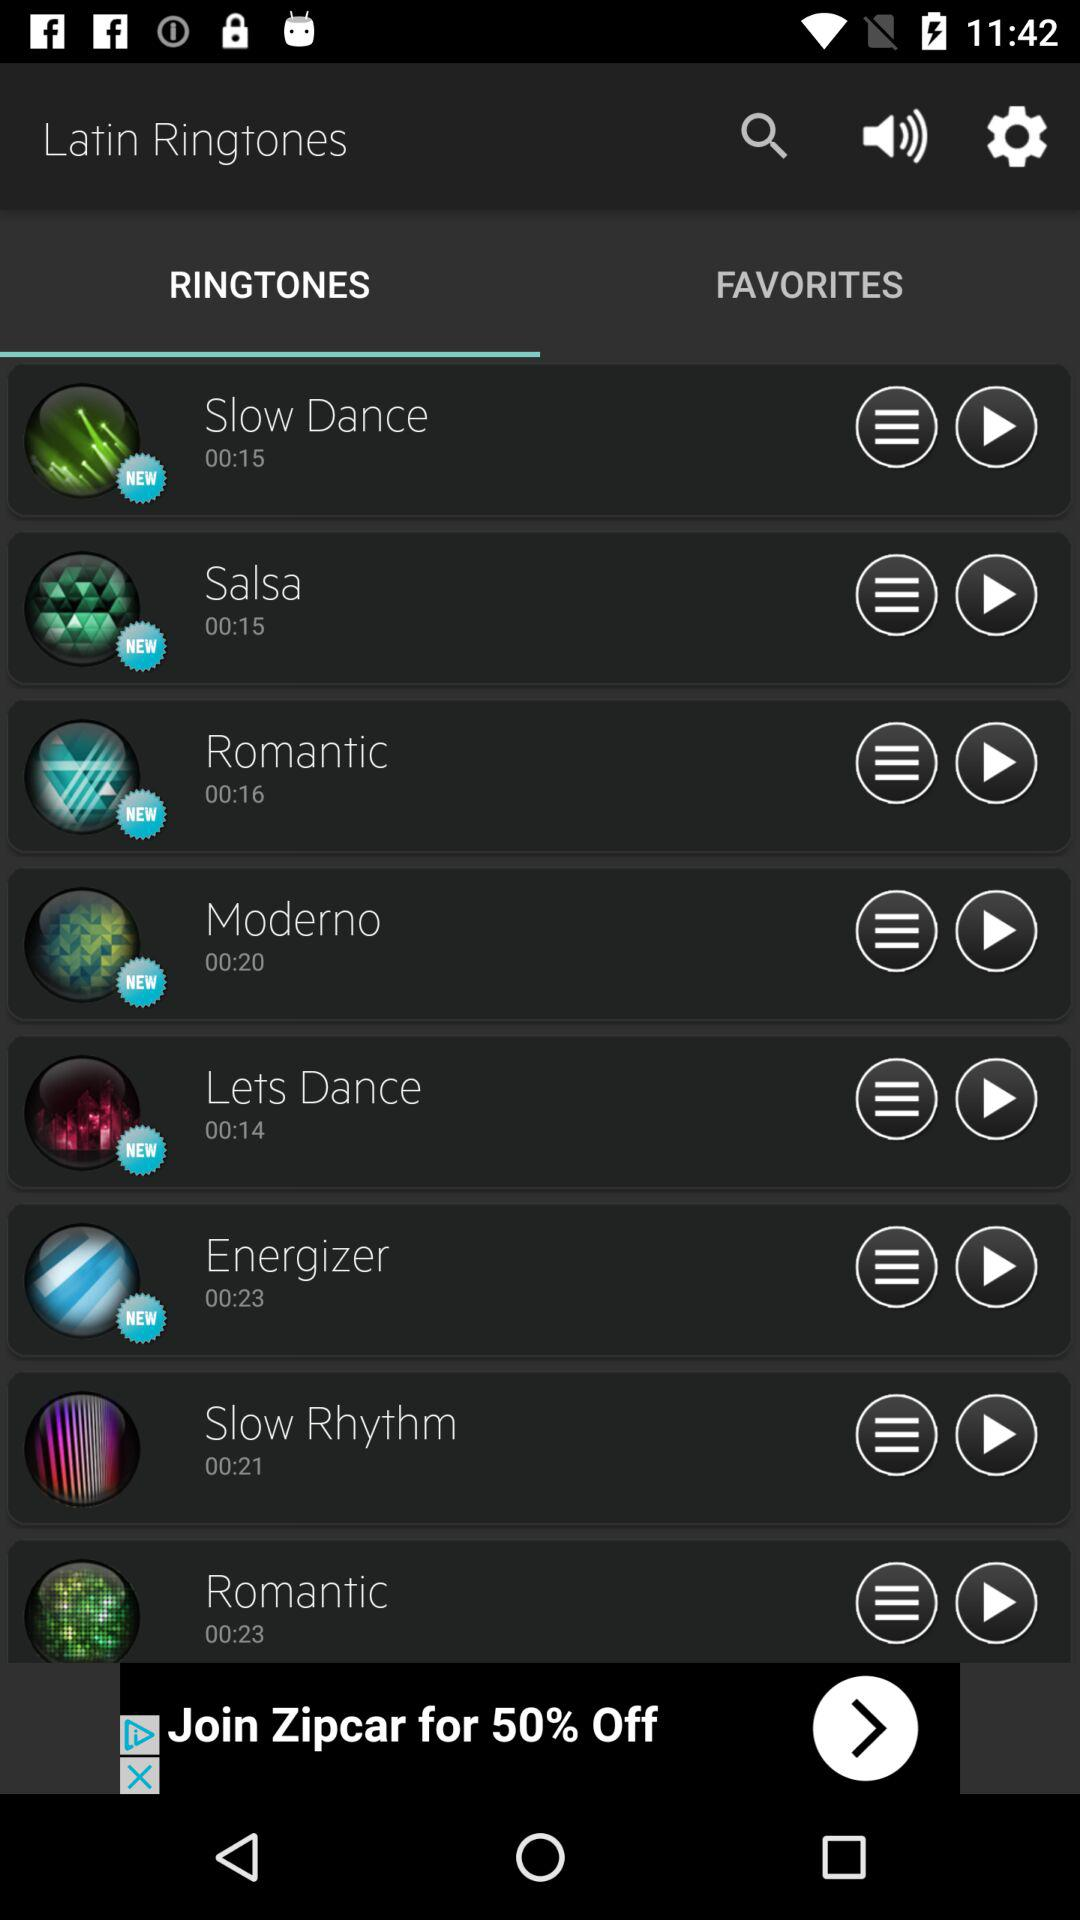Is the ringtone "Lets Dance" new or old? The ringtone "Lets Dance" is new. 